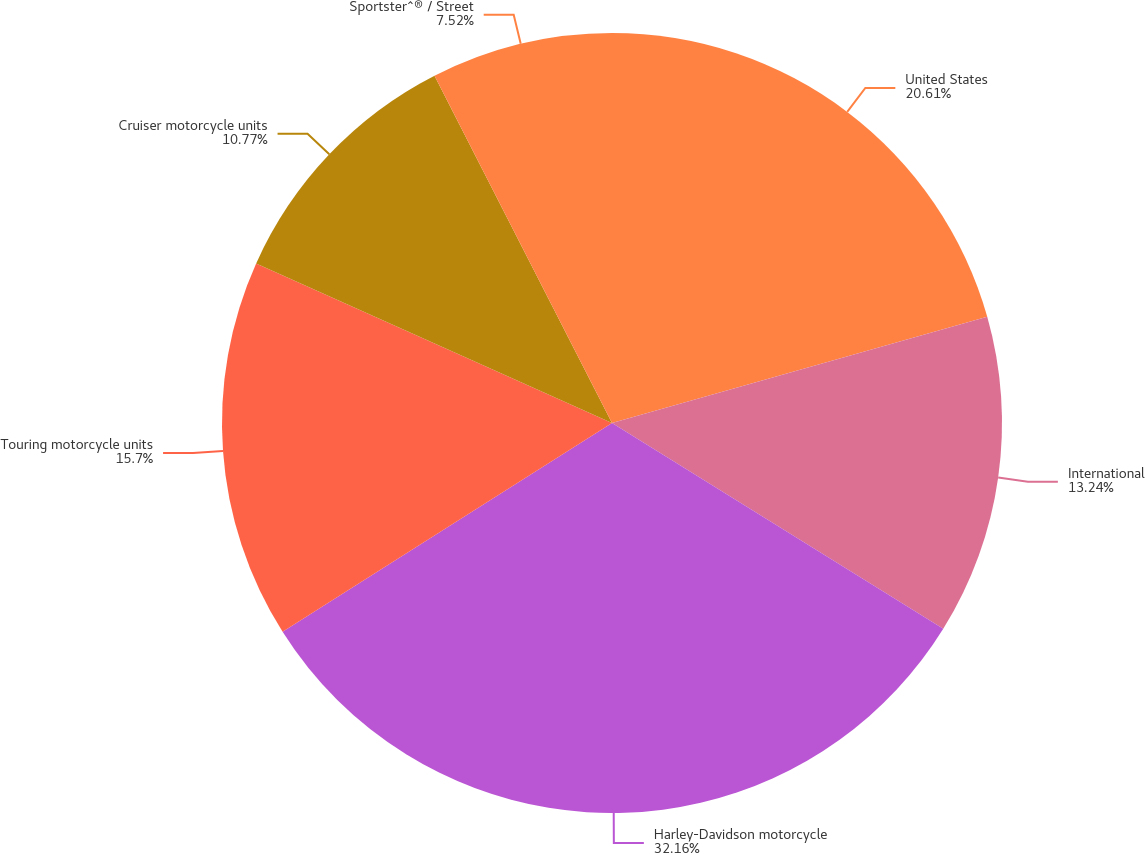Convert chart. <chart><loc_0><loc_0><loc_500><loc_500><pie_chart><fcel>United States<fcel>International<fcel>Harley-Davidson motorcycle<fcel>Touring motorcycle units<fcel>Cruiser motorcycle units<fcel>Sportster^® / Street<nl><fcel>20.61%<fcel>13.24%<fcel>32.16%<fcel>15.7%<fcel>10.77%<fcel>7.52%<nl></chart> 